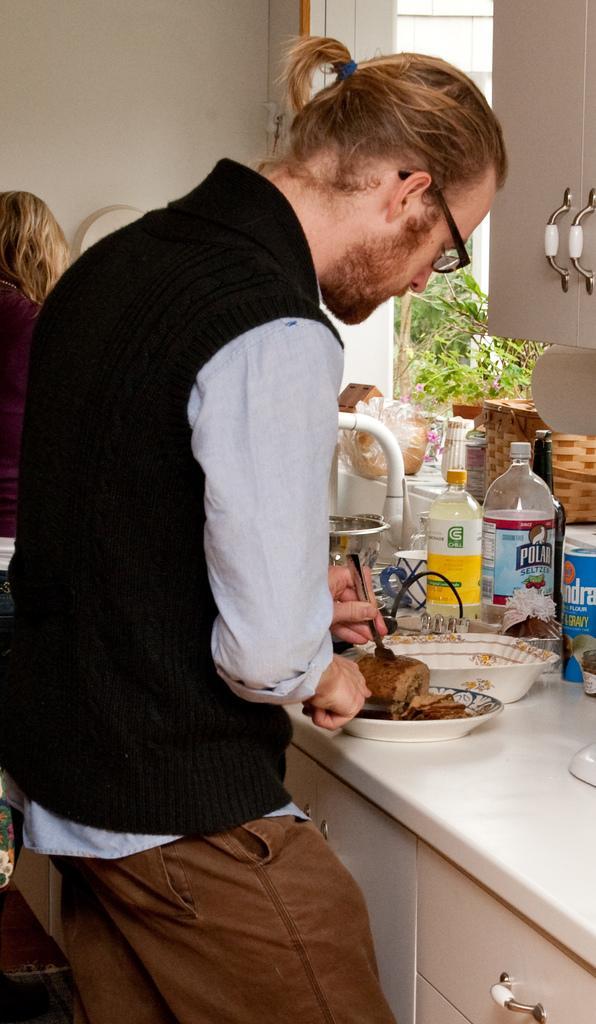How would you summarize this image in a sentence or two? In this image I can see a person cutting a food item. There are few bottles and food items on the table. I can see a cupboard. In the background there is a window. On the left side I can see a woman. 